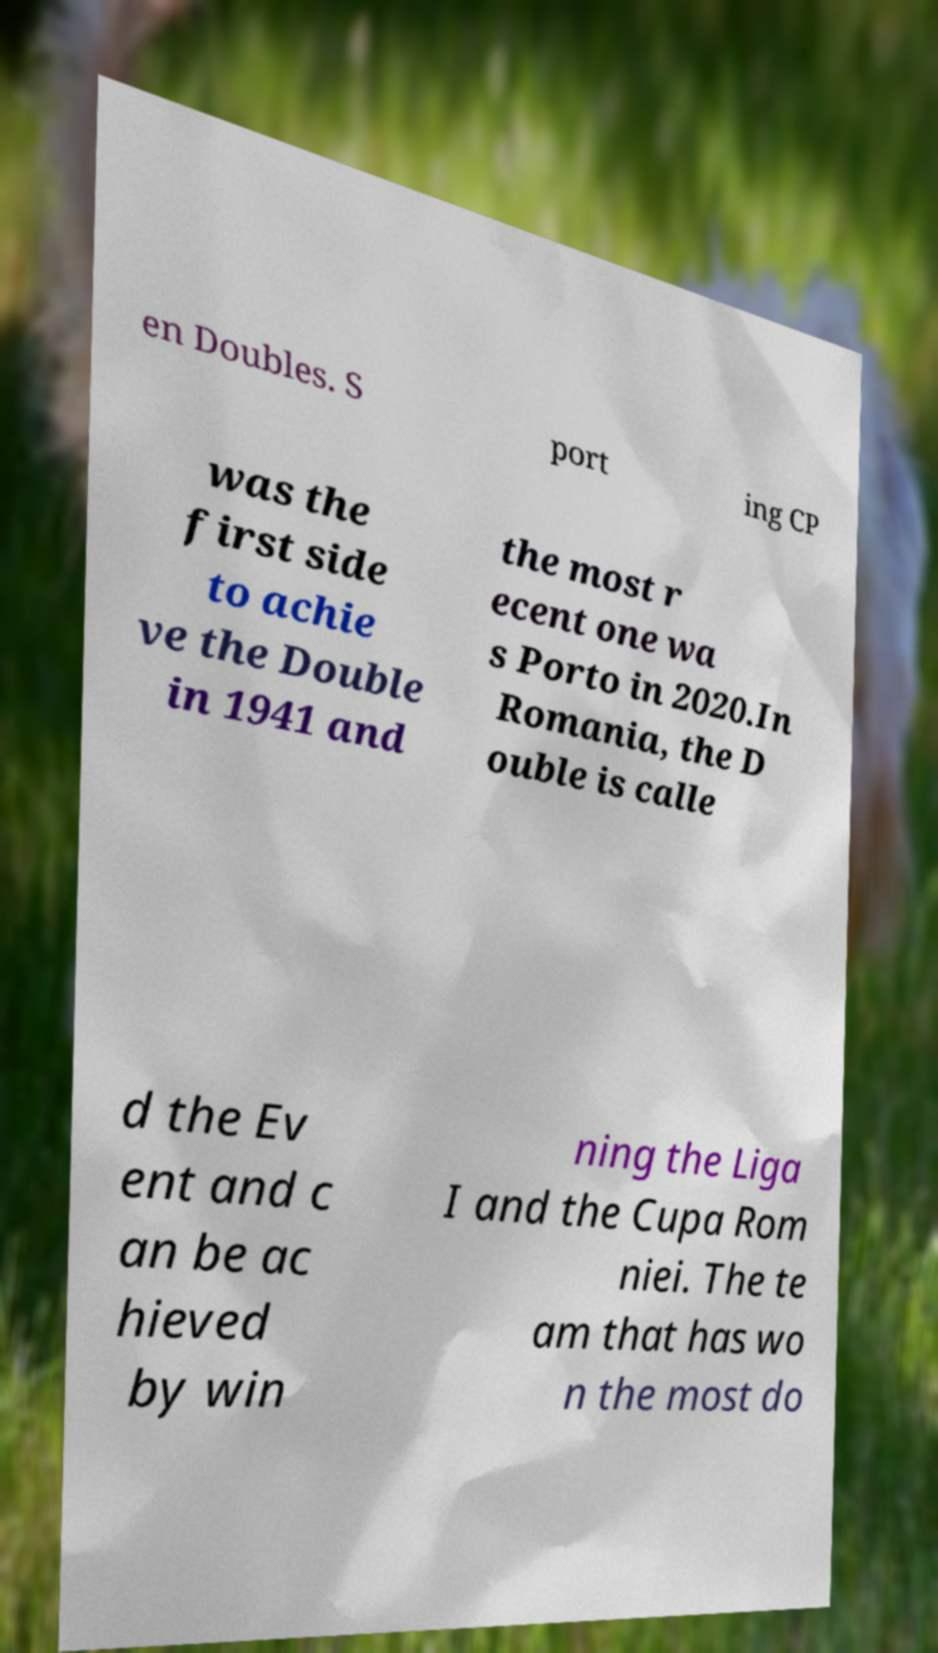Could you assist in decoding the text presented in this image and type it out clearly? en Doubles. S port ing CP was the first side to achie ve the Double in 1941 and the most r ecent one wa s Porto in 2020.In Romania, the D ouble is calle d the Ev ent and c an be ac hieved by win ning the Liga I and the Cupa Rom niei. The te am that has wo n the most do 